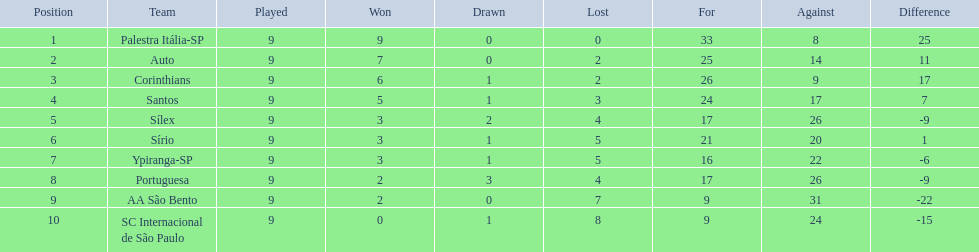How many teams played football in brazil during the year 1926? Palestra Itália-SP, Auto, Corinthians, Santos, Sílex, Sírio, Ypiranga-SP, Portuguesa, AA São Bento, SC Internacional de São Paulo. What was the highest number of games won during the 1926 season? 9. Which team was in the top spot with 9 wins for the 1926 season? Palestra Itália-SP. 